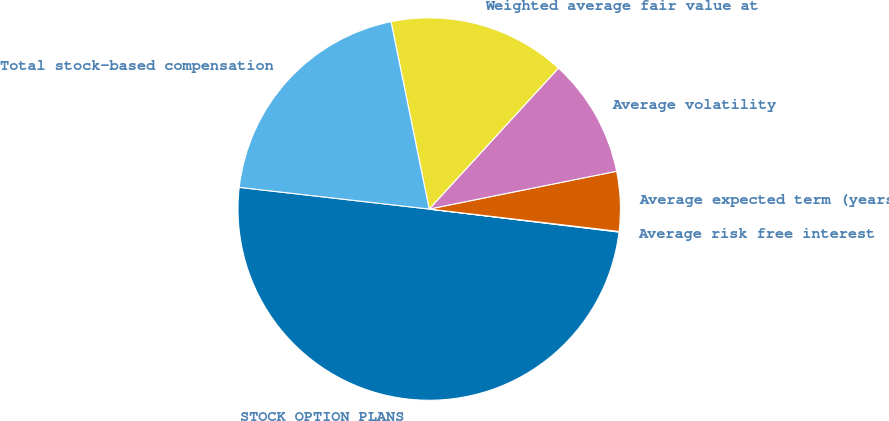Convert chart to OTSL. <chart><loc_0><loc_0><loc_500><loc_500><pie_chart><fcel>STOCK OPTION PLANS<fcel>Average risk free interest<fcel>Average expected term (years)<fcel>Average volatility<fcel>Weighted average fair value at<fcel>Total stock-based compensation<nl><fcel>49.89%<fcel>0.05%<fcel>5.04%<fcel>10.02%<fcel>15.01%<fcel>19.99%<nl></chart> 